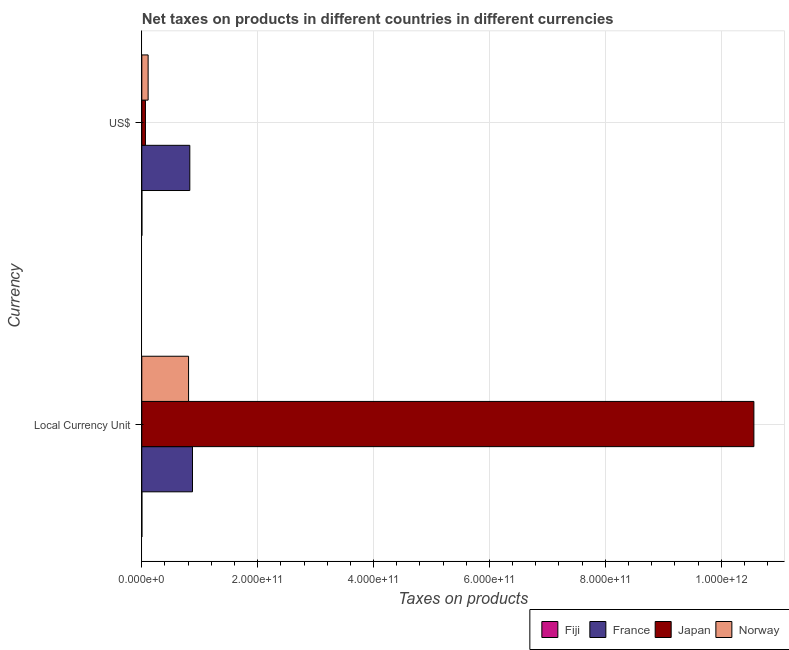How many different coloured bars are there?
Make the answer very short. 4. Are the number of bars per tick equal to the number of legend labels?
Offer a terse response. Yes. Are the number of bars on each tick of the Y-axis equal?
Your response must be concise. Yes. How many bars are there on the 2nd tick from the top?
Provide a succinct answer. 4. What is the label of the 2nd group of bars from the top?
Ensure brevity in your answer.  Local Currency Unit. What is the net taxes in us$ in France?
Offer a very short reply. 8.29e+1. Across all countries, what is the maximum net taxes in us$?
Offer a terse response. 8.29e+1. Across all countries, what is the minimum net taxes in constant 2005 us$?
Your answer should be very brief. 1.36e+08. In which country was the net taxes in constant 2005 us$ minimum?
Offer a terse response. Fiji. What is the total net taxes in us$ in the graph?
Make the answer very short. 1.00e+11. What is the difference between the net taxes in us$ in Japan and that in Norway?
Offer a terse response. -4.65e+09. What is the difference between the net taxes in constant 2005 us$ in France and the net taxes in us$ in Norway?
Provide a succinct answer. 7.66e+1. What is the average net taxes in constant 2005 us$ per country?
Provide a succinct answer. 3.06e+11. What is the difference between the net taxes in constant 2005 us$ and net taxes in us$ in Fiji?
Offer a very short reply. 1.59e+07. In how many countries, is the net taxes in us$ greater than 1000000000000 units?
Provide a succinct answer. 0. What is the ratio of the net taxes in us$ in France to that in Norway?
Your answer should be compact. 7.59. In how many countries, is the net taxes in constant 2005 us$ greater than the average net taxes in constant 2005 us$ taken over all countries?
Provide a succinct answer. 1. What does the 3rd bar from the top in Local Currency Unit represents?
Your answer should be very brief. France. How many bars are there?
Offer a very short reply. 8. How many countries are there in the graph?
Your response must be concise. 4. What is the difference between two consecutive major ticks on the X-axis?
Your response must be concise. 2.00e+11. Are the values on the major ticks of X-axis written in scientific E-notation?
Provide a succinct answer. Yes. Does the graph contain grids?
Provide a short and direct response. Yes. What is the title of the graph?
Offer a very short reply. Net taxes on products in different countries in different currencies. Does "Japan" appear as one of the legend labels in the graph?
Offer a very short reply. Yes. What is the label or title of the X-axis?
Make the answer very short. Taxes on products. What is the label or title of the Y-axis?
Your answer should be compact. Currency. What is the Taxes on products in Fiji in Local Currency Unit?
Provide a succinct answer. 1.36e+08. What is the Taxes on products in France in Local Currency Unit?
Your response must be concise. 8.75e+1. What is the Taxes on products of Japan in Local Currency Unit?
Provide a short and direct response. 1.06e+12. What is the Taxes on products of Norway in Local Currency Unit?
Ensure brevity in your answer.  8.07e+1. What is the Taxes on products in Fiji in US$?
Provide a short and direct response. 1.20e+08. What is the Taxes on products in France in US$?
Your answer should be compact. 8.29e+1. What is the Taxes on products in Japan in US$?
Offer a terse response. 6.27e+09. What is the Taxes on products of Norway in US$?
Your answer should be very brief. 1.09e+1. Across all Currency, what is the maximum Taxes on products of Fiji?
Your answer should be very brief. 1.36e+08. Across all Currency, what is the maximum Taxes on products in France?
Offer a terse response. 8.75e+1. Across all Currency, what is the maximum Taxes on products in Japan?
Make the answer very short. 1.06e+12. Across all Currency, what is the maximum Taxes on products in Norway?
Ensure brevity in your answer.  8.07e+1. Across all Currency, what is the minimum Taxes on products in Fiji?
Ensure brevity in your answer.  1.20e+08. Across all Currency, what is the minimum Taxes on products in France?
Your answer should be very brief. 8.29e+1. Across all Currency, what is the minimum Taxes on products in Japan?
Your answer should be compact. 6.27e+09. Across all Currency, what is the minimum Taxes on products of Norway?
Keep it short and to the point. 1.09e+1. What is the total Taxes on products of Fiji in the graph?
Provide a short and direct response. 2.55e+08. What is the total Taxes on products of France in the graph?
Provide a short and direct response. 1.70e+11. What is the total Taxes on products of Japan in the graph?
Provide a succinct answer. 1.06e+12. What is the total Taxes on products of Norway in the graph?
Ensure brevity in your answer.  9.16e+1. What is the difference between the Taxes on products of Fiji in Local Currency Unit and that in US$?
Your response must be concise. 1.59e+07. What is the difference between the Taxes on products of France in Local Currency Unit and that in US$?
Keep it short and to the point. 4.63e+09. What is the difference between the Taxes on products of Japan in Local Currency Unit and that in US$?
Your answer should be very brief. 1.05e+12. What is the difference between the Taxes on products in Norway in Local Currency Unit and that in US$?
Provide a short and direct response. 6.98e+1. What is the difference between the Taxes on products in Fiji in Local Currency Unit and the Taxes on products in France in US$?
Your answer should be very brief. -8.27e+1. What is the difference between the Taxes on products in Fiji in Local Currency Unit and the Taxes on products in Japan in US$?
Your answer should be very brief. -6.13e+09. What is the difference between the Taxes on products in Fiji in Local Currency Unit and the Taxes on products in Norway in US$?
Provide a succinct answer. -1.08e+1. What is the difference between the Taxes on products in France in Local Currency Unit and the Taxes on products in Japan in US$?
Your response must be concise. 8.12e+1. What is the difference between the Taxes on products in France in Local Currency Unit and the Taxes on products in Norway in US$?
Your response must be concise. 7.66e+1. What is the difference between the Taxes on products of Japan in Local Currency Unit and the Taxes on products of Norway in US$?
Ensure brevity in your answer.  1.05e+12. What is the average Taxes on products in Fiji per Currency?
Provide a short and direct response. 1.28e+08. What is the average Taxes on products in France per Currency?
Offer a very short reply. 8.52e+1. What is the average Taxes on products of Japan per Currency?
Make the answer very short. 5.31e+11. What is the average Taxes on products of Norway per Currency?
Provide a succinct answer. 4.58e+1. What is the difference between the Taxes on products of Fiji and Taxes on products of France in Local Currency Unit?
Offer a terse response. -8.74e+1. What is the difference between the Taxes on products in Fiji and Taxes on products in Japan in Local Currency Unit?
Offer a very short reply. -1.06e+12. What is the difference between the Taxes on products in Fiji and Taxes on products in Norway in Local Currency Unit?
Offer a terse response. -8.06e+1. What is the difference between the Taxes on products in France and Taxes on products in Japan in Local Currency Unit?
Your answer should be compact. -9.69e+11. What is the difference between the Taxes on products of France and Taxes on products of Norway in Local Currency Unit?
Your answer should be compact. 6.80e+09. What is the difference between the Taxes on products of Japan and Taxes on products of Norway in Local Currency Unit?
Make the answer very short. 9.76e+11. What is the difference between the Taxes on products in Fiji and Taxes on products in France in US$?
Offer a terse response. -8.28e+1. What is the difference between the Taxes on products in Fiji and Taxes on products in Japan in US$?
Provide a succinct answer. -6.15e+09. What is the difference between the Taxes on products in Fiji and Taxes on products in Norway in US$?
Keep it short and to the point. -1.08e+1. What is the difference between the Taxes on products of France and Taxes on products of Japan in US$?
Your answer should be compact. 7.66e+1. What is the difference between the Taxes on products of France and Taxes on products of Norway in US$?
Your answer should be very brief. 7.20e+1. What is the difference between the Taxes on products of Japan and Taxes on products of Norway in US$?
Offer a terse response. -4.65e+09. What is the ratio of the Taxes on products of Fiji in Local Currency Unit to that in US$?
Make the answer very short. 1.13. What is the ratio of the Taxes on products of France in Local Currency Unit to that in US$?
Keep it short and to the point. 1.06. What is the ratio of the Taxes on products in Japan in Local Currency Unit to that in US$?
Your response must be concise. 168.52. What is the ratio of the Taxes on products in Norway in Local Currency Unit to that in US$?
Your answer should be compact. 7.39. What is the difference between the highest and the second highest Taxes on products of Fiji?
Offer a very short reply. 1.59e+07. What is the difference between the highest and the second highest Taxes on products in France?
Your answer should be compact. 4.63e+09. What is the difference between the highest and the second highest Taxes on products of Japan?
Ensure brevity in your answer.  1.05e+12. What is the difference between the highest and the second highest Taxes on products in Norway?
Make the answer very short. 6.98e+1. What is the difference between the highest and the lowest Taxes on products of Fiji?
Provide a short and direct response. 1.59e+07. What is the difference between the highest and the lowest Taxes on products in France?
Make the answer very short. 4.63e+09. What is the difference between the highest and the lowest Taxes on products of Japan?
Offer a terse response. 1.05e+12. What is the difference between the highest and the lowest Taxes on products in Norway?
Your answer should be compact. 6.98e+1. 